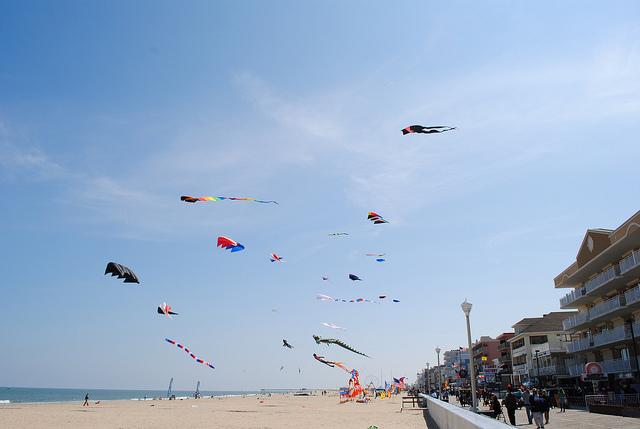What color is the building in front of the people?
Give a very brief answer. Tan. Is there a boardwalk?
Write a very short answer. Yes. Is there a bridge located in this picture?
Give a very brief answer. No. Where is the picture taken?
Quick response, please. Beach. Is it a windy day?
Short answer required. Yes. What is flying in the air?
Keep it brief. Kites. 